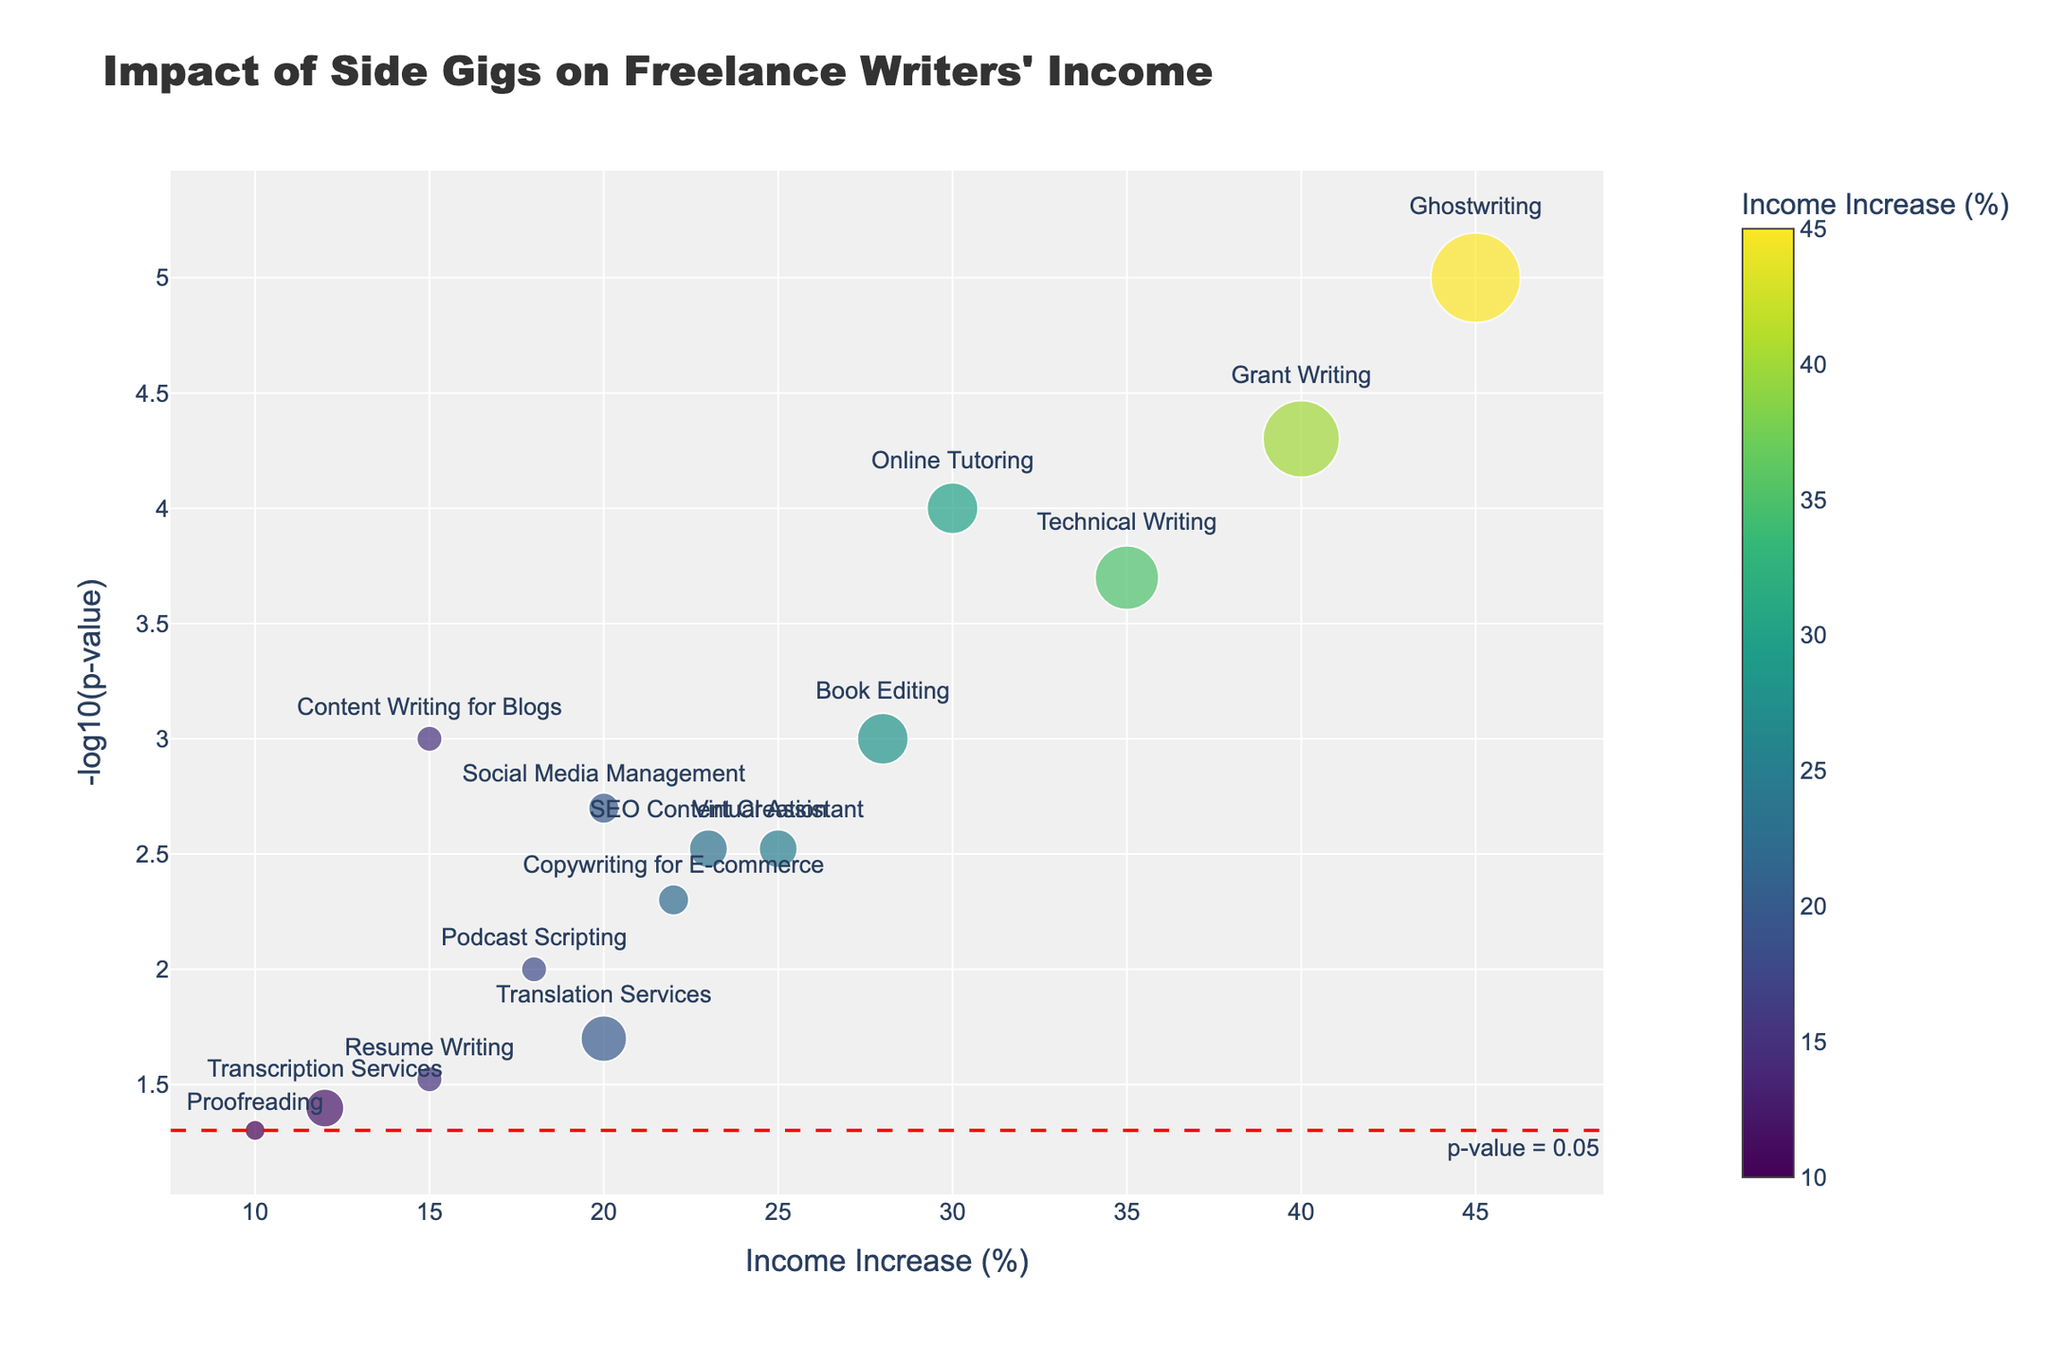What is the title of the plot? The title is located at the top of the plot, and it reads 'Impact of Side Gigs on Freelance Writers' Income'.
Answer: Impact of Side Gigs on Freelance Writers' Income What does the x-axis represent? The x-axis represents the percentage increase in income from various side gigs. This is indicated by the label 'Income Increase (%)'.
Answer: Income Increase (%) Which side gig shows the highest increase in income? To determine the side gig with the highest income increase, look at the data points on the x-axis. The gig furthest to the right has the highest income increase. The furthest point on the x-axis is for Ghostwriting with 45%.
Answer: Ghostwriting What is the p-value threshold as represented by the horizontal dashed line? The plot includes a horizontal dashed line, annotated as "p-value = 0.05". The y-axis has been transformed to -log10(p-value), so this line is at y = -log10(0.05) which equals approximately 1.3.
Answer: 0.05 Which side gig requires the most time commitment per week? The data point with the largest marker size represents the side gig requiring the most time commitment. The marker size of the dots is proportional to the time commitment in hours per week. Ghostwriting has the largest marker, indicating it requires 35 hours per week.
Answer: Ghostwriting What is the relationship between income increase and p-value for Technical Writing? For Technical Writing, find the corresponding point on the plot and look at its x and y coordinates. It shows an income increase of 35% and a p-value, indicated by its -log10 transformation, resulting in approximately 3.70.
Answer: 35% income increase, p-value around 0.0002 Which side gig has an income increase of 20% but different time commitments? There are two side gigs, Social Media Management and Translation Services, both showing a 20% income increase. Social Media Management requires 12 hours/week whereas Translation Services requires 18 hours/week.
Answer: Social Media Management and Translation Services Which side gig has the smallest p-value? The smallest p-value will have the largest -log10(p-value). Look for the highest point on the y-axis. The highest point corresponds to Ghostwriting with a p-value of 0.00001.
Answer: Ghostwriting Compare the income increase and time commitment for Content Writing for Blogs and Podcast Scripting. Content Writing for Blogs has a 15% income increase and requires 10 hours/week. Podcast Scripting has an 18% income increase and also requires 10 hours/week.
Answer: Content Writing for Blogs: 15%, 10 hours/week; Podcast Scripting: 18%, 10 hours/week 